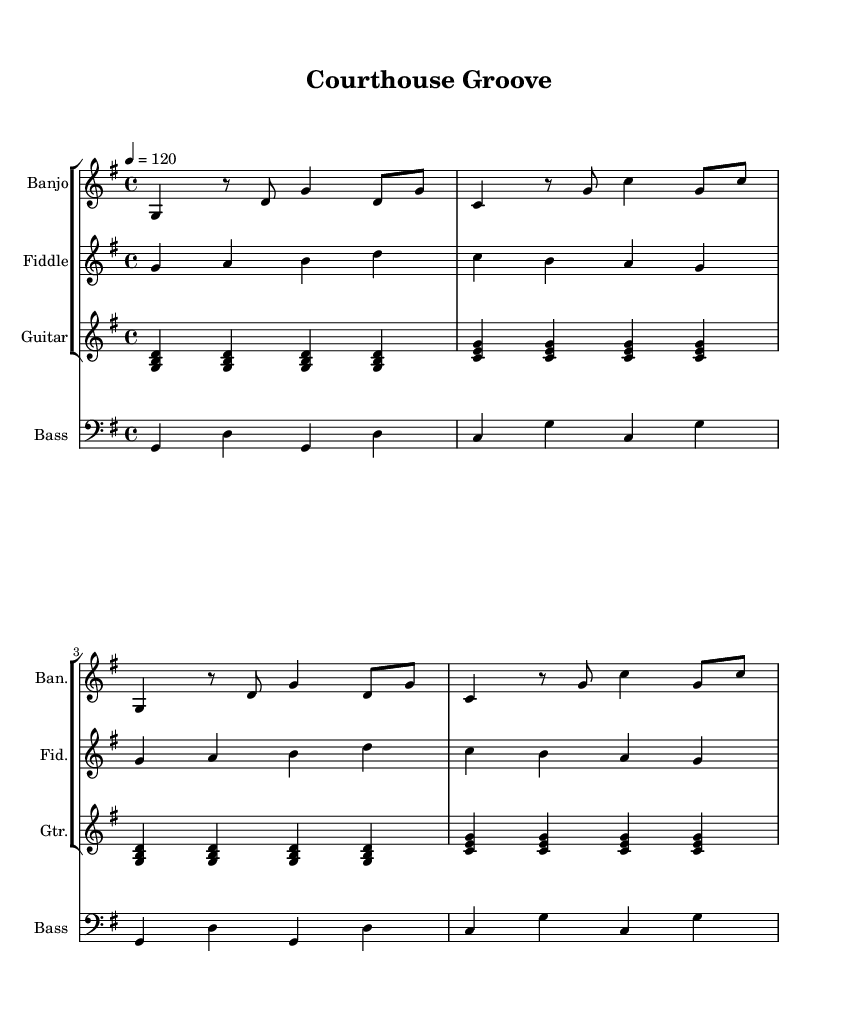What is the key signature of this music? The key signature is G major, which has one sharp (F#). This can be determined by looking at the key signature indicated at the beginning of the score.
Answer: G major What is the time signature of this music? The time signature is 4/4, which indicates that there are four beats per measure and the quarter note gets one beat. This is indicated at the start of the sheet music.
Answer: 4/4 What is the tempo marking for this piece? The tempo marking is 120 beats per minute, as indicated by the notation at the beginning of the score. This tells us the speed at which the piece should be played.
Answer: 120 How many instruments are featured in this composition? There are four instruments featured: banjo, fiddle, guitar, and bass. This can be identified by the separate staves labeled for each instrument in the score.
Answer: Four Which instrument plays the lowest pitch range? The bass plays the lowest pitch range as it is written in the bass clef, which is designed for lower-pitched instruments, unlike the other instruments that use treble clef.
Answer: Bass What pattern is repeated in the banjo part? The banjo part features a pattern of notes that includes alternating G and C, demonstrating the use of a short repeated motif that emphasizes the rhythm. This can be seen throughout the measures.
Answer: G and C pattern Which musical elements in this piece suggest a bluegrass influence? The use of a banjo and fiddle, typical instruments in bluegrass music, along with the upbeat tempo and rhythmic patterns, contribute to the bluegrass influence in this fusion track. The combination of these elements aligns with bluegrass's unique characteristics.
Answer: Banjo and fiddle 